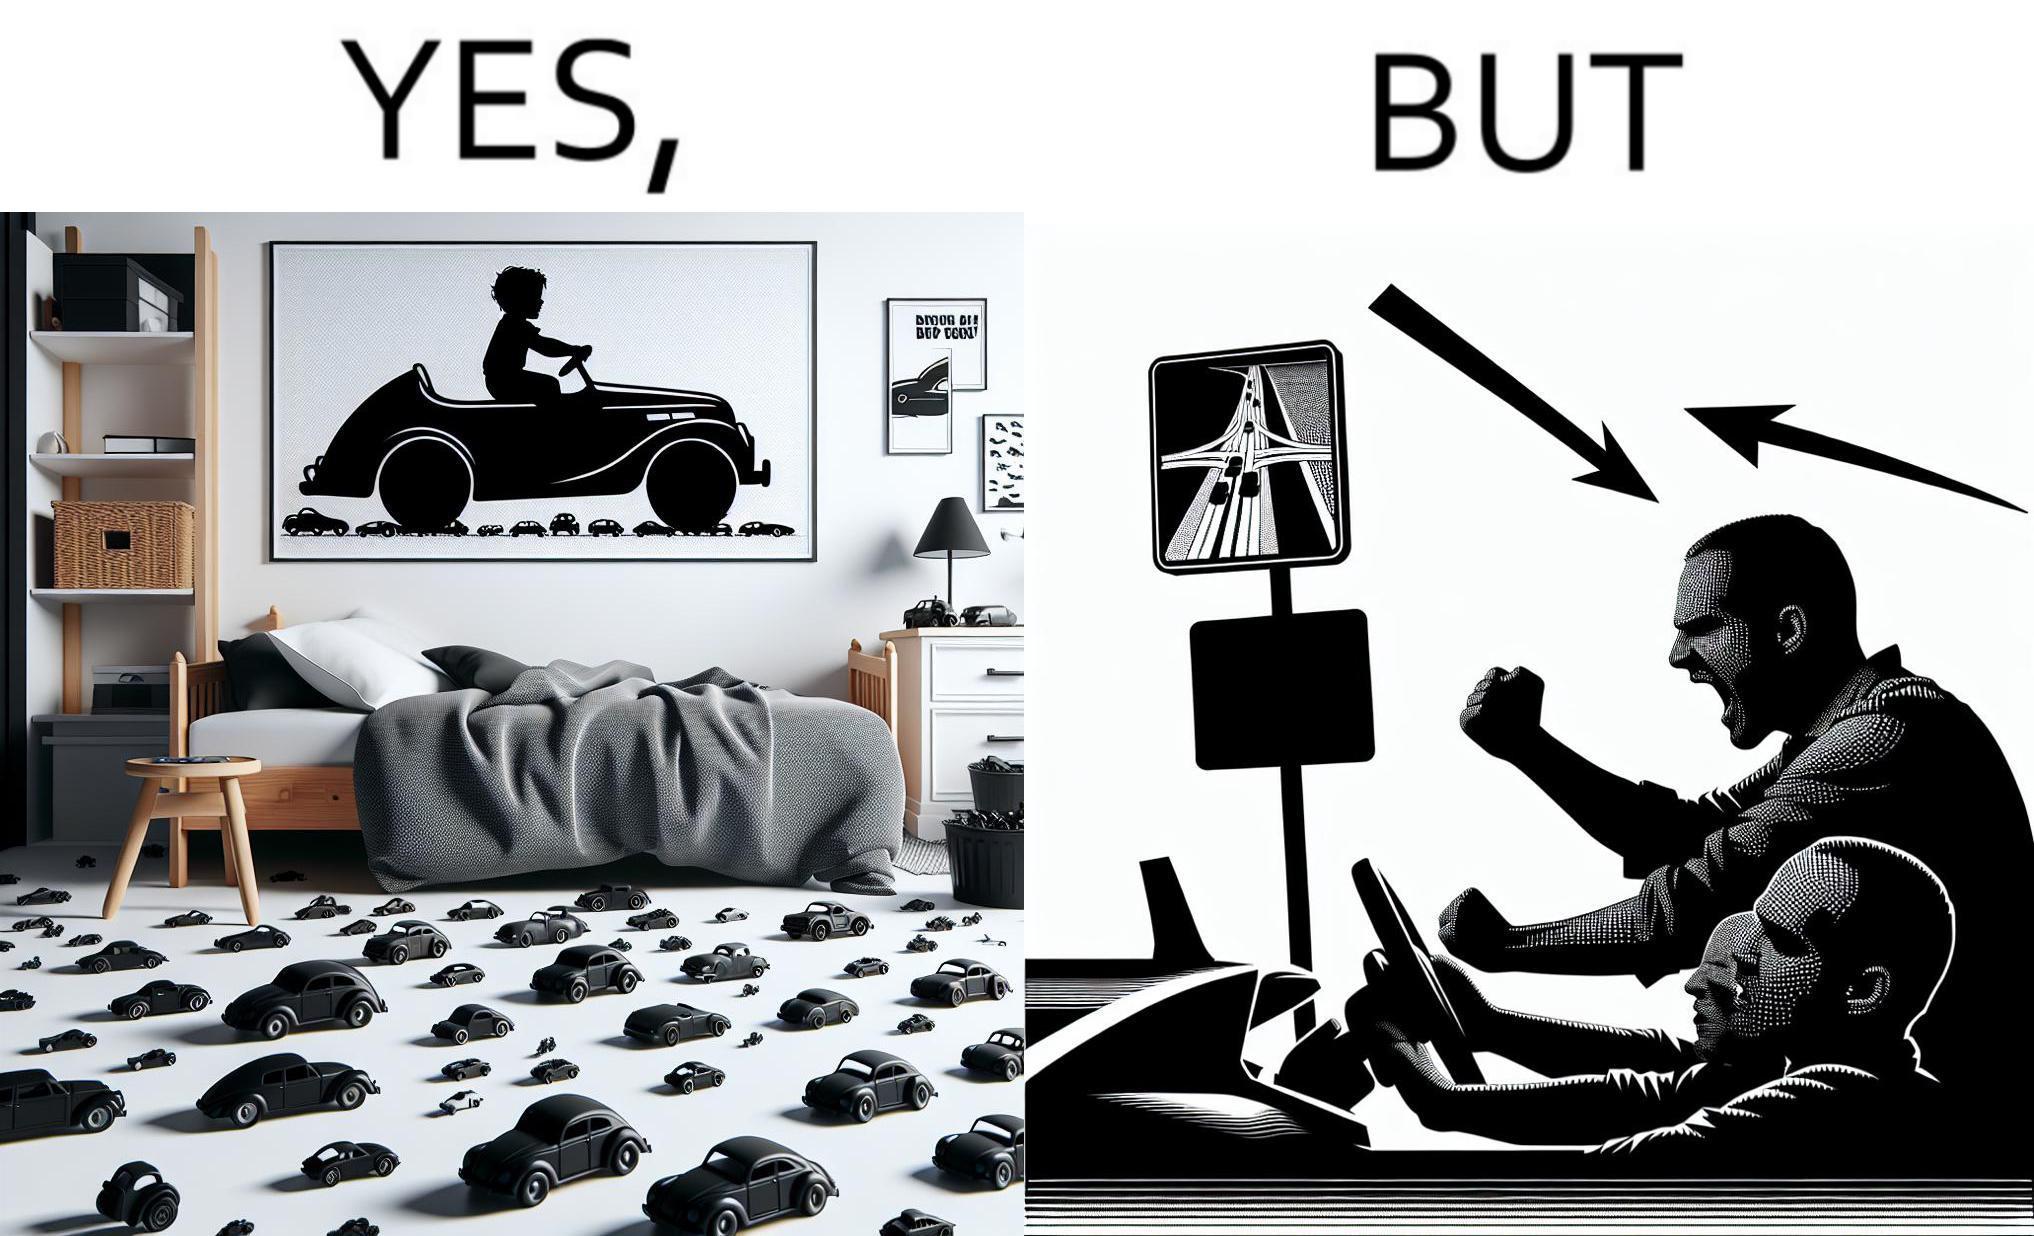Does this image contain satire or humor? Yes, this image is satirical. 